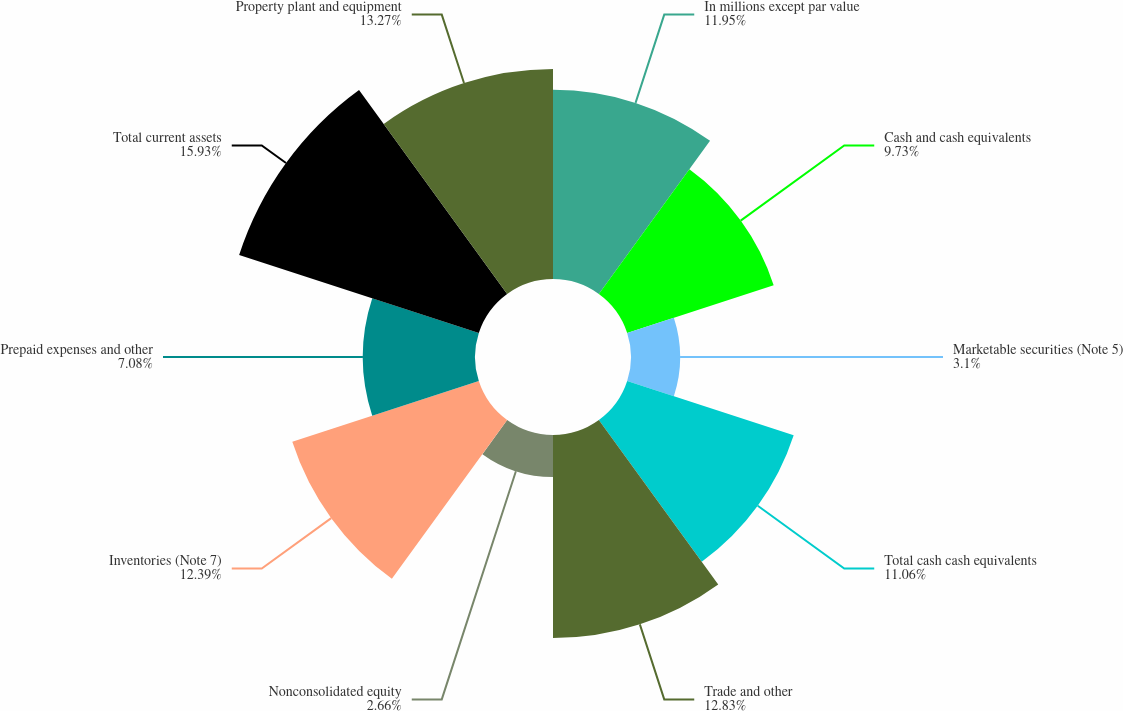Convert chart. <chart><loc_0><loc_0><loc_500><loc_500><pie_chart><fcel>In millions except par value<fcel>Cash and cash equivalents<fcel>Marketable securities (Note 5)<fcel>Total cash cash equivalents<fcel>Trade and other<fcel>Nonconsolidated equity<fcel>Inventories (Note 7)<fcel>Prepaid expenses and other<fcel>Total current assets<fcel>Property plant and equipment<nl><fcel>11.95%<fcel>9.73%<fcel>3.1%<fcel>11.06%<fcel>12.83%<fcel>2.66%<fcel>12.39%<fcel>7.08%<fcel>15.92%<fcel>13.27%<nl></chart> 